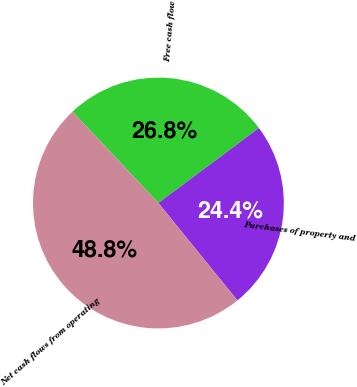Convert chart. <chart><loc_0><loc_0><loc_500><loc_500><pie_chart><fcel>Free cash flow<fcel>Purchases of property and<fcel>Net cash flows from operating<nl><fcel>26.8%<fcel>24.35%<fcel>48.85%<nl></chart> 